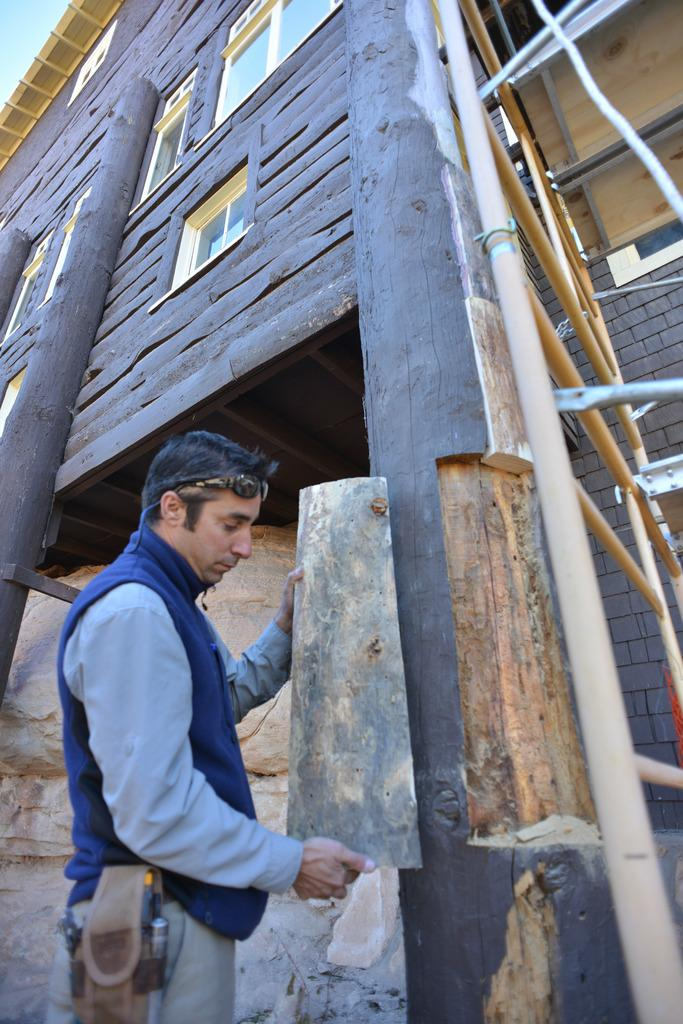What is the man in the image holding? The man is holding a wooden object. What type of structure is visible in the image? There is a wooden house with windows in the image. Can you describe any other objects or features in the image? There is a ladder and wooden pillars visible in the image. What is the natural element present in the image? There is a rock in the image. What type of vest is the man wearing in the image? The image does not show the man wearing a vest, so it cannot be determined from the image. 